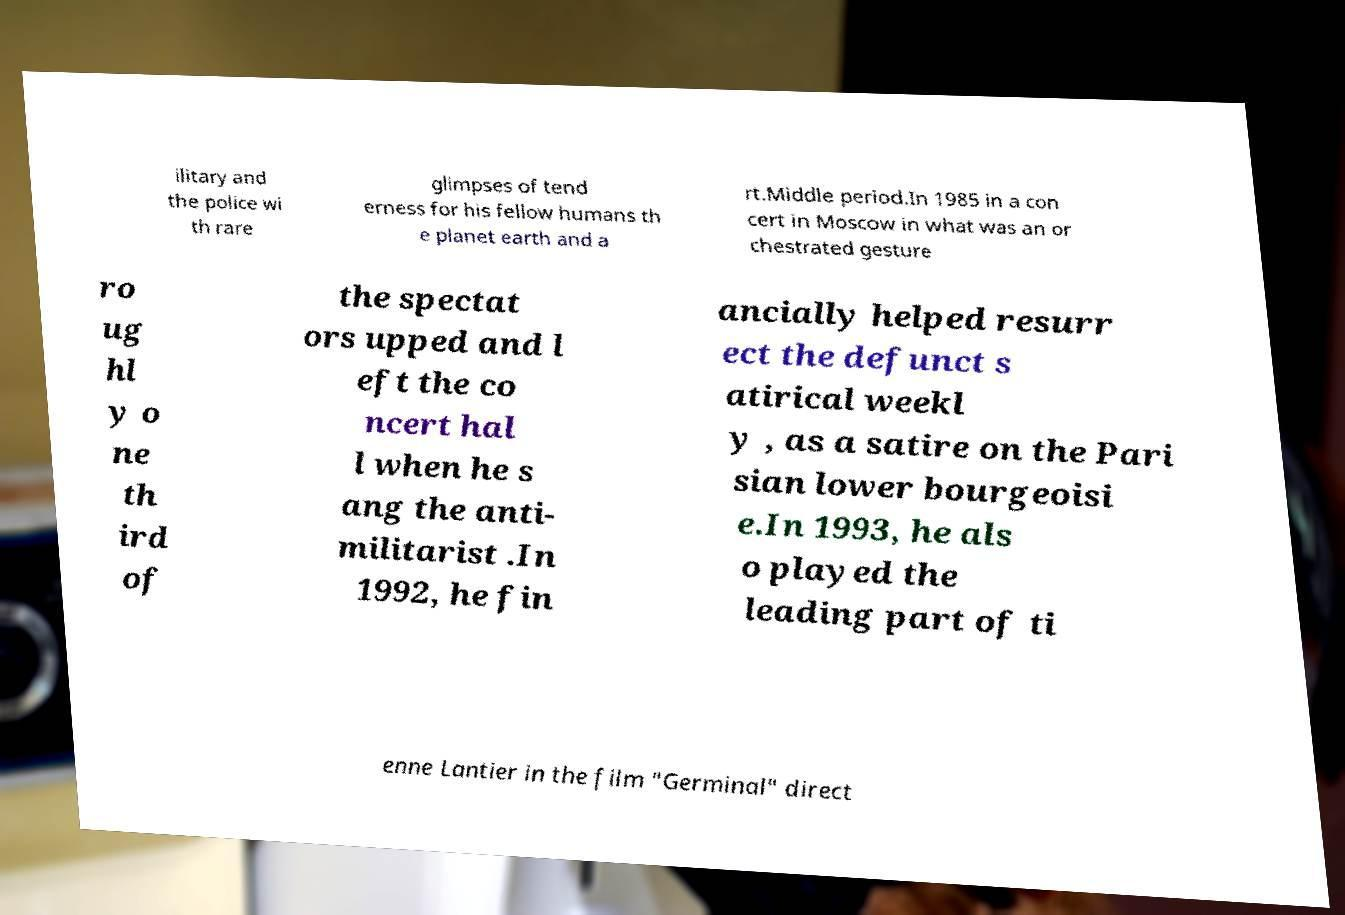Can you read and provide the text displayed in the image?This photo seems to have some interesting text. Can you extract and type it out for me? ilitary and the police wi th rare glimpses of tend erness for his fellow humans th e planet earth and a rt.Middle period.In 1985 in a con cert in Moscow in what was an or chestrated gesture ro ug hl y o ne th ird of the spectat ors upped and l eft the co ncert hal l when he s ang the anti- militarist .In 1992, he fin ancially helped resurr ect the defunct s atirical weekl y , as a satire on the Pari sian lower bourgeoisi e.In 1993, he als o played the leading part of ti enne Lantier in the film "Germinal" direct 